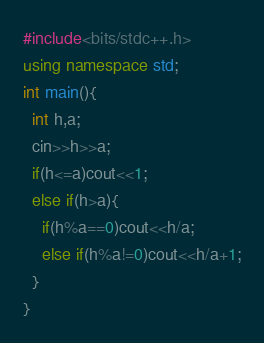Convert code to text. <code><loc_0><loc_0><loc_500><loc_500><_C++_>#include<bits/stdc++.h>
using namespace std;
int main(){
  int h,a;
  cin>>h>>a;
  if(h<=a)cout<<1;
  else if(h>a){
    if(h%a==0)cout<<h/a;
  	else if(h%a!=0)cout<<h/a+1;
  }
}</code> 